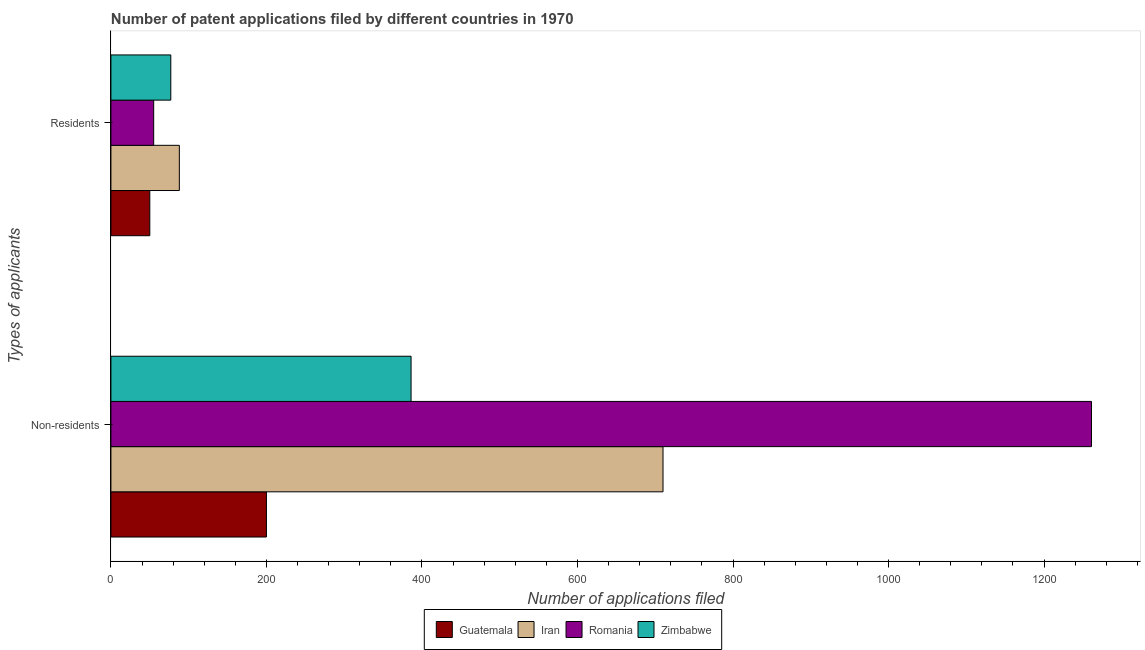How many different coloured bars are there?
Your answer should be very brief. 4. How many groups of bars are there?
Give a very brief answer. 2. Are the number of bars per tick equal to the number of legend labels?
Your response must be concise. Yes. Are the number of bars on each tick of the Y-axis equal?
Your response must be concise. Yes. What is the label of the 2nd group of bars from the top?
Make the answer very short. Non-residents. What is the number of patent applications by non residents in Iran?
Provide a short and direct response. 710. Across all countries, what is the maximum number of patent applications by non residents?
Your answer should be very brief. 1261. Across all countries, what is the minimum number of patent applications by non residents?
Provide a short and direct response. 200. In which country was the number of patent applications by residents maximum?
Your response must be concise. Iran. In which country was the number of patent applications by non residents minimum?
Your response must be concise. Guatemala. What is the total number of patent applications by non residents in the graph?
Make the answer very short. 2557. What is the difference between the number of patent applications by residents in Guatemala and that in Iran?
Offer a very short reply. -38. What is the difference between the number of patent applications by non residents in Guatemala and the number of patent applications by residents in Romania?
Make the answer very short. 145. What is the average number of patent applications by residents per country?
Provide a short and direct response. 67.5. What is the difference between the number of patent applications by residents and number of patent applications by non residents in Romania?
Your response must be concise. -1206. What is the ratio of the number of patent applications by non residents in Romania to that in Zimbabwe?
Offer a terse response. 3.27. In how many countries, is the number of patent applications by residents greater than the average number of patent applications by residents taken over all countries?
Offer a very short reply. 2. What does the 3rd bar from the top in Residents represents?
Provide a succinct answer. Iran. What does the 2nd bar from the bottom in Non-residents represents?
Provide a succinct answer. Iran. Are all the bars in the graph horizontal?
Make the answer very short. Yes. Are the values on the major ticks of X-axis written in scientific E-notation?
Provide a succinct answer. No. Does the graph contain grids?
Provide a succinct answer. No. How many legend labels are there?
Provide a succinct answer. 4. How are the legend labels stacked?
Offer a very short reply. Horizontal. What is the title of the graph?
Your answer should be very brief. Number of patent applications filed by different countries in 1970. Does "Sao Tome and Principe" appear as one of the legend labels in the graph?
Provide a succinct answer. No. What is the label or title of the X-axis?
Your answer should be very brief. Number of applications filed. What is the label or title of the Y-axis?
Offer a terse response. Types of applicants. What is the Number of applications filed in Iran in Non-residents?
Provide a succinct answer. 710. What is the Number of applications filed in Romania in Non-residents?
Offer a very short reply. 1261. What is the Number of applications filed in Zimbabwe in Non-residents?
Offer a very short reply. 386. What is the Number of applications filed in Guatemala in Residents?
Offer a terse response. 50. What is the Number of applications filed in Iran in Residents?
Provide a short and direct response. 88. What is the Number of applications filed in Romania in Residents?
Offer a very short reply. 55. Across all Types of applicants, what is the maximum Number of applications filed in Guatemala?
Offer a very short reply. 200. Across all Types of applicants, what is the maximum Number of applications filed of Iran?
Ensure brevity in your answer.  710. Across all Types of applicants, what is the maximum Number of applications filed in Romania?
Your answer should be very brief. 1261. Across all Types of applicants, what is the maximum Number of applications filed of Zimbabwe?
Keep it short and to the point. 386. Across all Types of applicants, what is the minimum Number of applications filed in Iran?
Keep it short and to the point. 88. Across all Types of applicants, what is the minimum Number of applications filed of Romania?
Your response must be concise. 55. What is the total Number of applications filed in Guatemala in the graph?
Provide a short and direct response. 250. What is the total Number of applications filed of Iran in the graph?
Your answer should be compact. 798. What is the total Number of applications filed of Romania in the graph?
Ensure brevity in your answer.  1316. What is the total Number of applications filed in Zimbabwe in the graph?
Your answer should be compact. 463. What is the difference between the Number of applications filed of Guatemala in Non-residents and that in Residents?
Make the answer very short. 150. What is the difference between the Number of applications filed of Iran in Non-residents and that in Residents?
Give a very brief answer. 622. What is the difference between the Number of applications filed in Romania in Non-residents and that in Residents?
Offer a terse response. 1206. What is the difference between the Number of applications filed of Zimbabwe in Non-residents and that in Residents?
Give a very brief answer. 309. What is the difference between the Number of applications filed of Guatemala in Non-residents and the Number of applications filed of Iran in Residents?
Give a very brief answer. 112. What is the difference between the Number of applications filed of Guatemala in Non-residents and the Number of applications filed of Romania in Residents?
Your answer should be compact. 145. What is the difference between the Number of applications filed in Guatemala in Non-residents and the Number of applications filed in Zimbabwe in Residents?
Provide a short and direct response. 123. What is the difference between the Number of applications filed of Iran in Non-residents and the Number of applications filed of Romania in Residents?
Offer a terse response. 655. What is the difference between the Number of applications filed in Iran in Non-residents and the Number of applications filed in Zimbabwe in Residents?
Your response must be concise. 633. What is the difference between the Number of applications filed of Romania in Non-residents and the Number of applications filed of Zimbabwe in Residents?
Your response must be concise. 1184. What is the average Number of applications filed in Guatemala per Types of applicants?
Offer a terse response. 125. What is the average Number of applications filed of Iran per Types of applicants?
Make the answer very short. 399. What is the average Number of applications filed of Romania per Types of applicants?
Give a very brief answer. 658. What is the average Number of applications filed of Zimbabwe per Types of applicants?
Your answer should be compact. 231.5. What is the difference between the Number of applications filed in Guatemala and Number of applications filed in Iran in Non-residents?
Provide a succinct answer. -510. What is the difference between the Number of applications filed in Guatemala and Number of applications filed in Romania in Non-residents?
Provide a short and direct response. -1061. What is the difference between the Number of applications filed in Guatemala and Number of applications filed in Zimbabwe in Non-residents?
Ensure brevity in your answer.  -186. What is the difference between the Number of applications filed of Iran and Number of applications filed of Romania in Non-residents?
Provide a succinct answer. -551. What is the difference between the Number of applications filed of Iran and Number of applications filed of Zimbabwe in Non-residents?
Make the answer very short. 324. What is the difference between the Number of applications filed of Romania and Number of applications filed of Zimbabwe in Non-residents?
Keep it short and to the point. 875. What is the difference between the Number of applications filed in Guatemala and Number of applications filed in Iran in Residents?
Offer a terse response. -38. What is the difference between the Number of applications filed of Guatemala and Number of applications filed of Romania in Residents?
Offer a terse response. -5. What is the difference between the Number of applications filed in Guatemala and Number of applications filed in Zimbabwe in Residents?
Offer a very short reply. -27. What is the ratio of the Number of applications filed of Iran in Non-residents to that in Residents?
Your response must be concise. 8.07. What is the ratio of the Number of applications filed in Romania in Non-residents to that in Residents?
Offer a very short reply. 22.93. What is the ratio of the Number of applications filed of Zimbabwe in Non-residents to that in Residents?
Your answer should be very brief. 5.01. What is the difference between the highest and the second highest Number of applications filed of Guatemala?
Ensure brevity in your answer.  150. What is the difference between the highest and the second highest Number of applications filed of Iran?
Your answer should be compact. 622. What is the difference between the highest and the second highest Number of applications filed of Romania?
Offer a terse response. 1206. What is the difference between the highest and the second highest Number of applications filed of Zimbabwe?
Provide a succinct answer. 309. What is the difference between the highest and the lowest Number of applications filed in Guatemala?
Your response must be concise. 150. What is the difference between the highest and the lowest Number of applications filed in Iran?
Provide a short and direct response. 622. What is the difference between the highest and the lowest Number of applications filed of Romania?
Ensure brevity in your answer.  1206. What is the difference between the highest and the lowest Number of applications filed of Zimbabwe?
Provide a succinct answer. 309. 